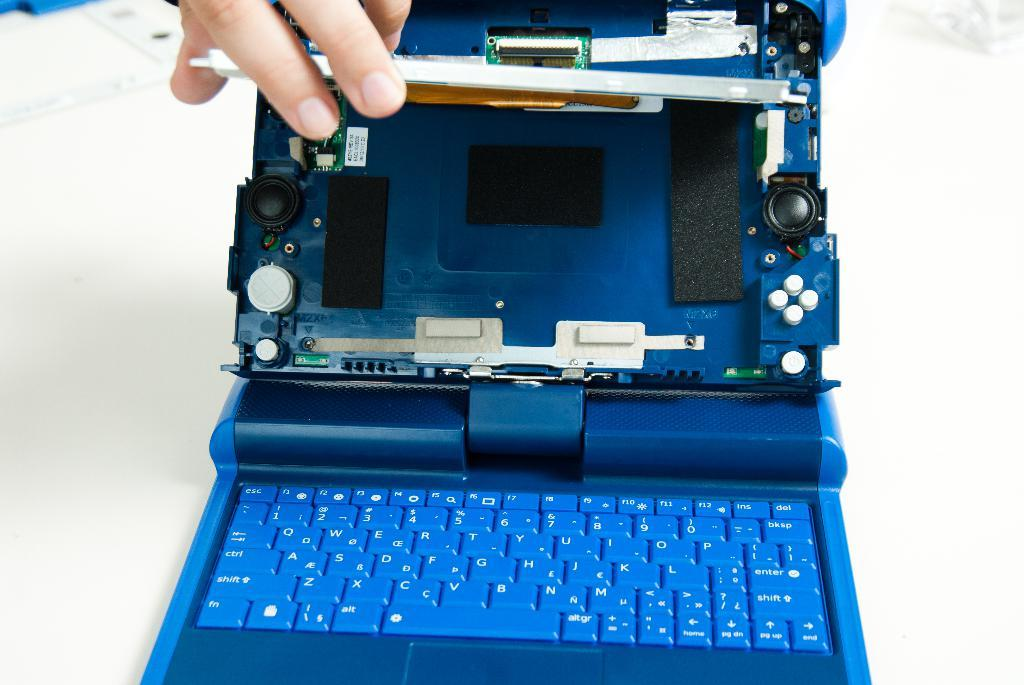<image>
Relay a brief, clear account of the picture shown. a small notebook in blue with the letters B and N  on the bottom row 